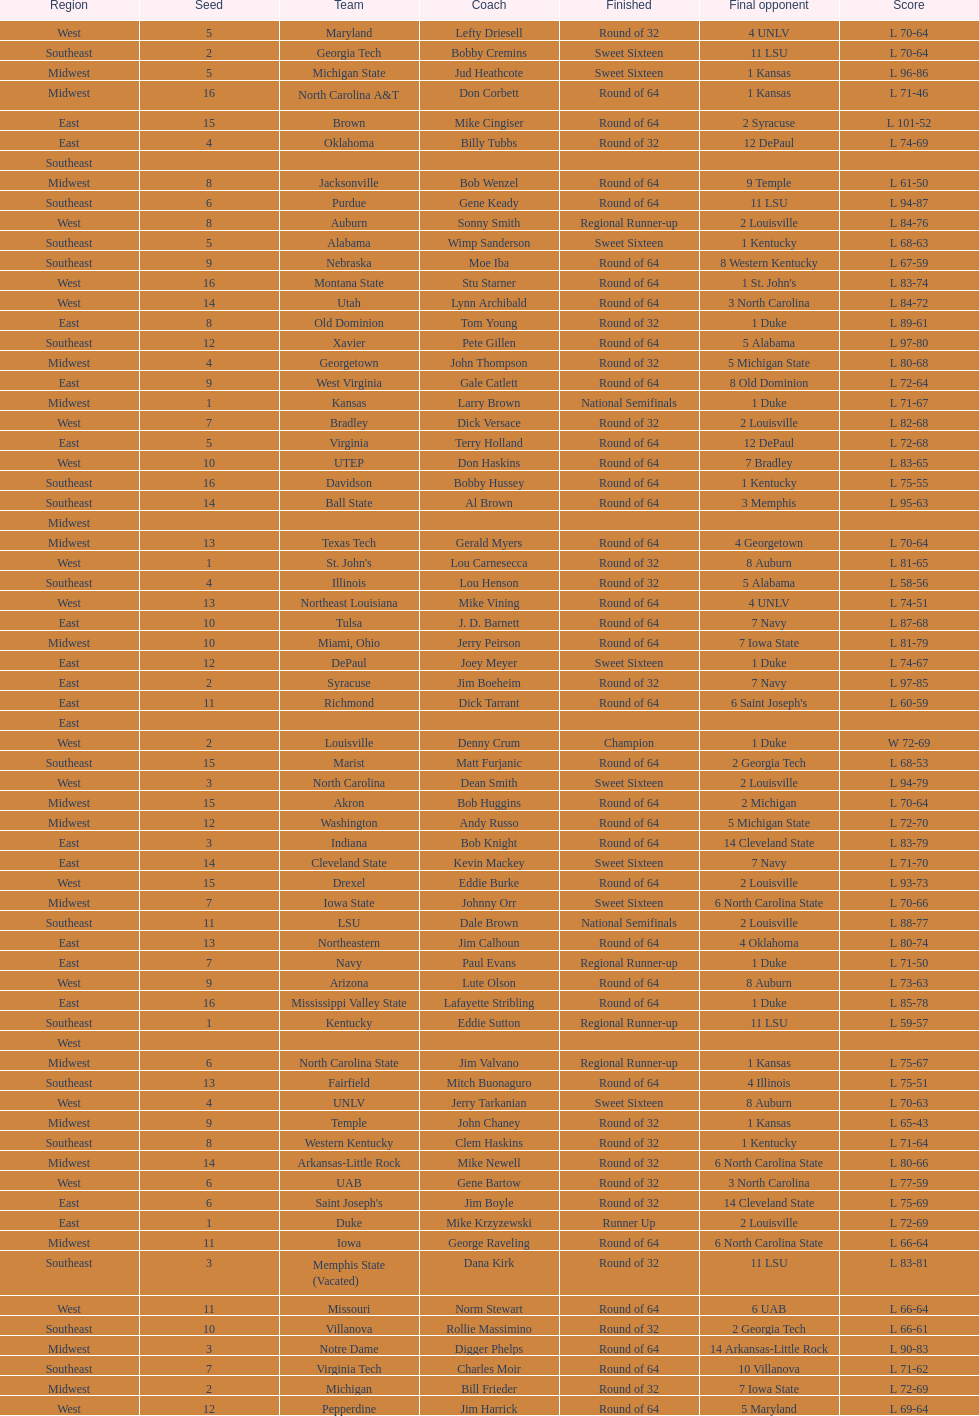North carolina and unlv each made it to which round? Sweet Sixteen. 